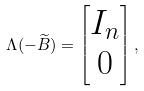Convert formula to latex. <formula><loc_0><loc_0><loc_500><loc_500>\Lambda ( - \widetilde { B } ) = \begin{bmatrix} I _ { n } \\ 0 \end{bmatrix} ,</formula> 